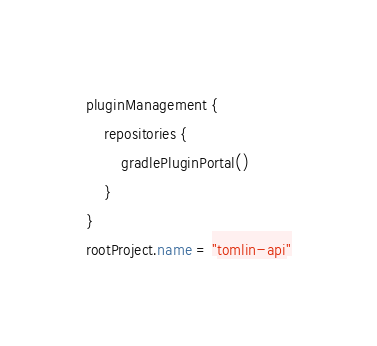<code> <loc_0><loc_0><loc_500><loc_500><_Kotlin_>pluginManagement {
    repositories {
        gradlePluginPortal()
    }
}
rootProject.name = "tomlin-api"
</code> 